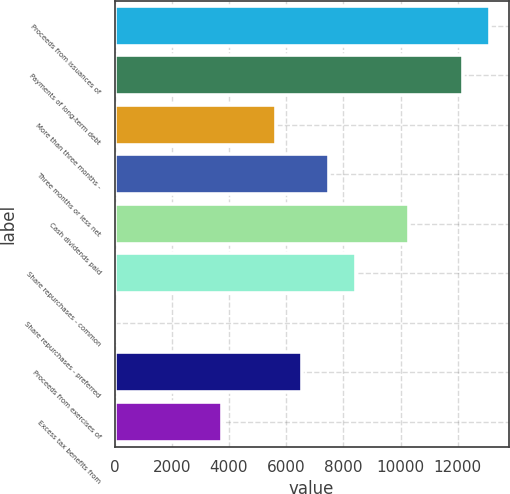Convert chart. <chart><loc_0><loc_0><loc_500><loc_500><bar_chart><fcel>Proceeds from issuances of<fcel>Payments of long-term debt<fcel>More than three months -<fcel>Three months or less net<fcel>Cash dividends paid<fcel>Share repurchases - common<fcel>Share repurchases - preferred<fcel>Proceeds from exercises of<fcel>Excess tax benefits from<nl><fcel>13122.2<fcel>12185.4<fcel>5627.8<fcel>7501.4<fcel>10311.8<fcel>8438.2<fcel>7<fcel>6564.6<fcel>3754.2<nl></chart> 